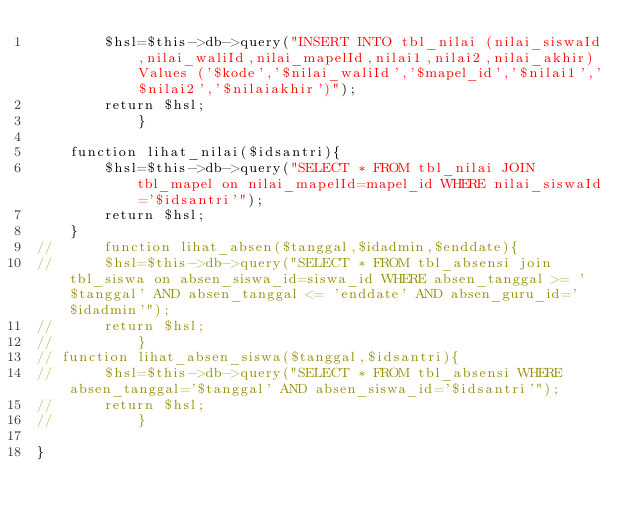<code> <loc_0><loc_0><loc_500><loc_500><_PHP_>		$hsl=$this->db->query("INSERT INTO tbl_nilai (nilai_siswaId,nilai_waliId,nilai_mapelId,nilai1,nilai2,nilai_akhir) Values ('$kode','$nilai_waliId','$mapel_id','$nilai1','$nilai2','$nilaiakhir')");
		return $hsl;
			}

	function lihat_nilai($idsantri){
		$hsl=$this->db->query("SELECT * FROM tbl_nilai JOIN tbl_mapel on nilai_mapelId=mapel_id WHERE nilai_siswaId='$idsantri'");
		return $hsl;
	}
// 		function lihat_absen($tanggal,$idadmin,$enddate){
// 		$hsl=$this->db->query("SELECT * FROM tbl_absensi join tbl_siswa on absen_siswa_id=siswa_id WHERE absen_tanggal >= '$tanggal' AND absen_tanggal <= 'enddate' AND absen_guru_id='$idadmin'");
// 		return $hsl;
// 			}
// function lihat_absen_siswa($tanggal,$idsantri){
// 		$hsl=$this->db->query("SELECT * FROM tbl_absensi WHERE absen_tanggal='$tanggal' AND absen_siswa_id='$idsantri'");
// 		return $hsl;
// 			}

}
</code> 